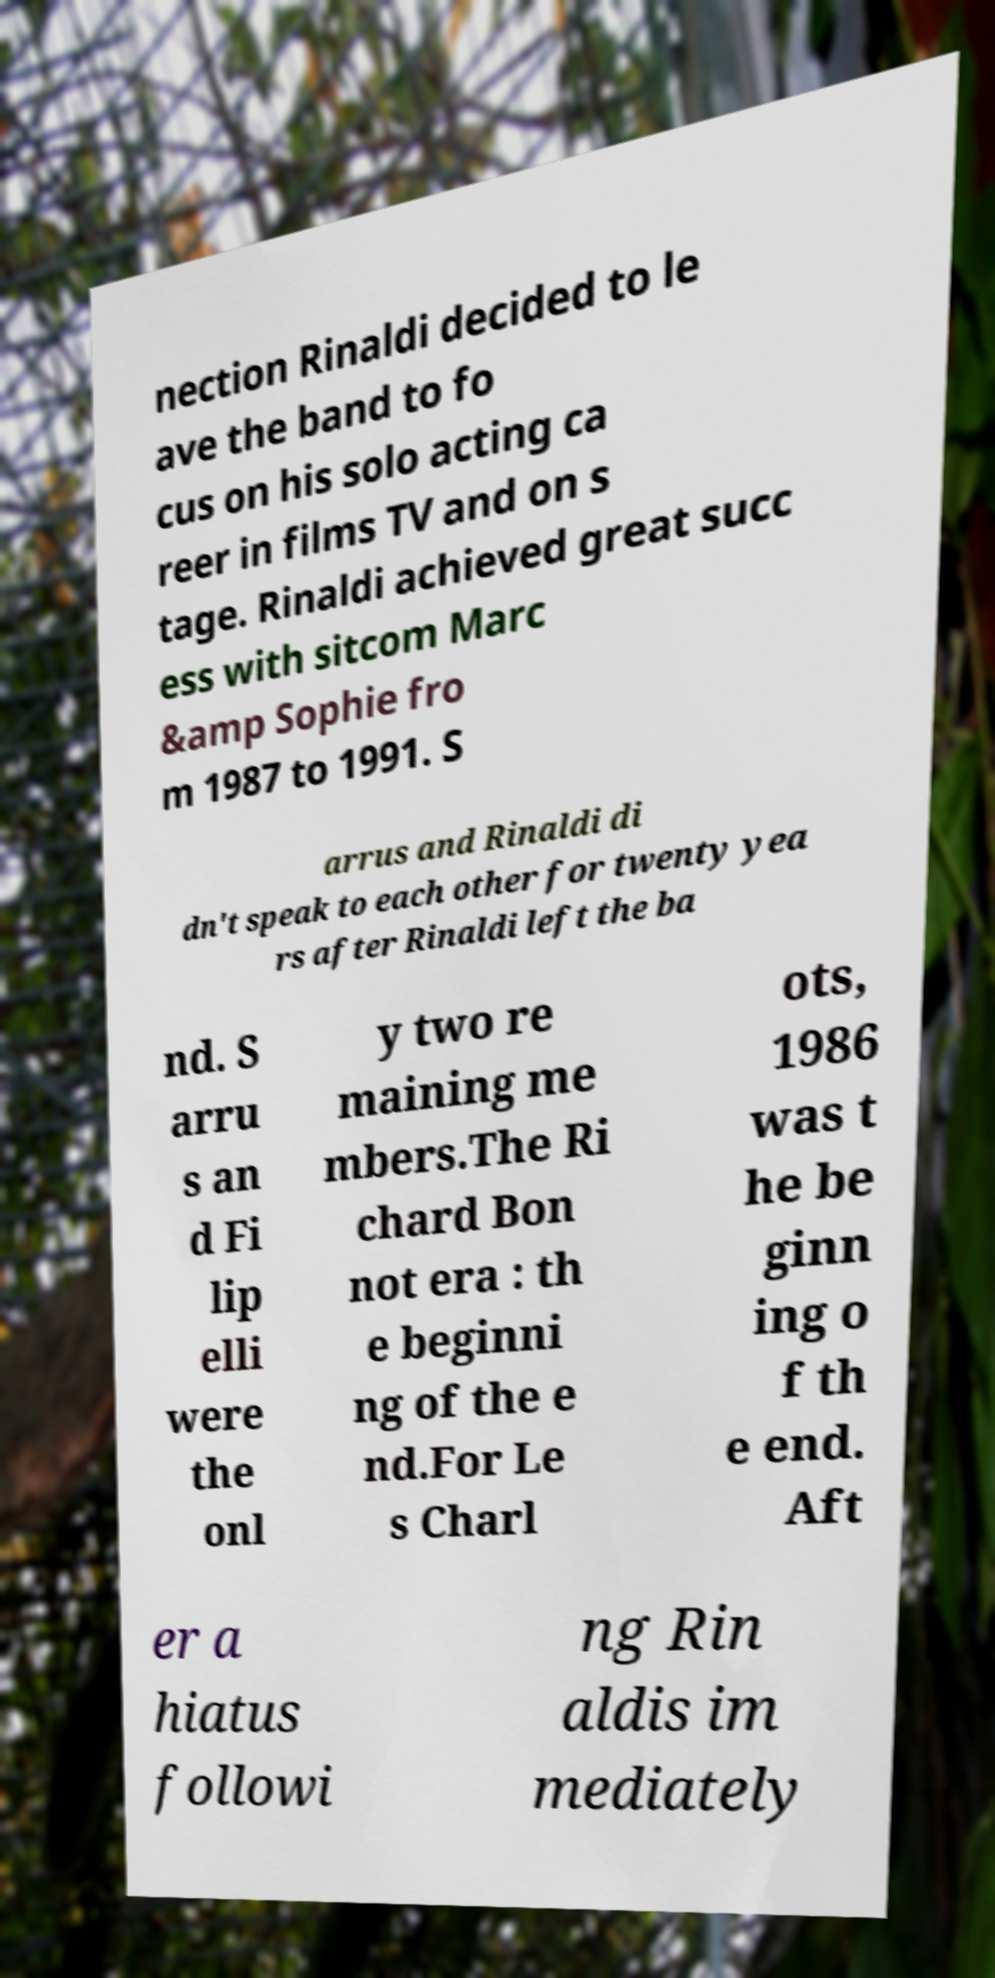There's text embedded in this image that I need extracted. Can you transcribe it verbatim? nection Rinaldi decided to le ave the band to fo cus on his solo acting ca reer in films TV and on s tage. Rinaldi achieved great succ ess with sitcom Marc &amp Sophie fro m 1987 to 1991. S arrus and Rinaldi di dn't speak to each other for twenty yea rs after Rinaldi left the ba nd. S arru s an d Fi lip elli were the onl y two re maining me mbers.The Ri chard Bon not era : th e beginni ng of the e nd.For Le s Charl ots, 1986 was t he be ginn ing o f th e end. Aft er a hiatus followi ng Rin aldis im mediately 